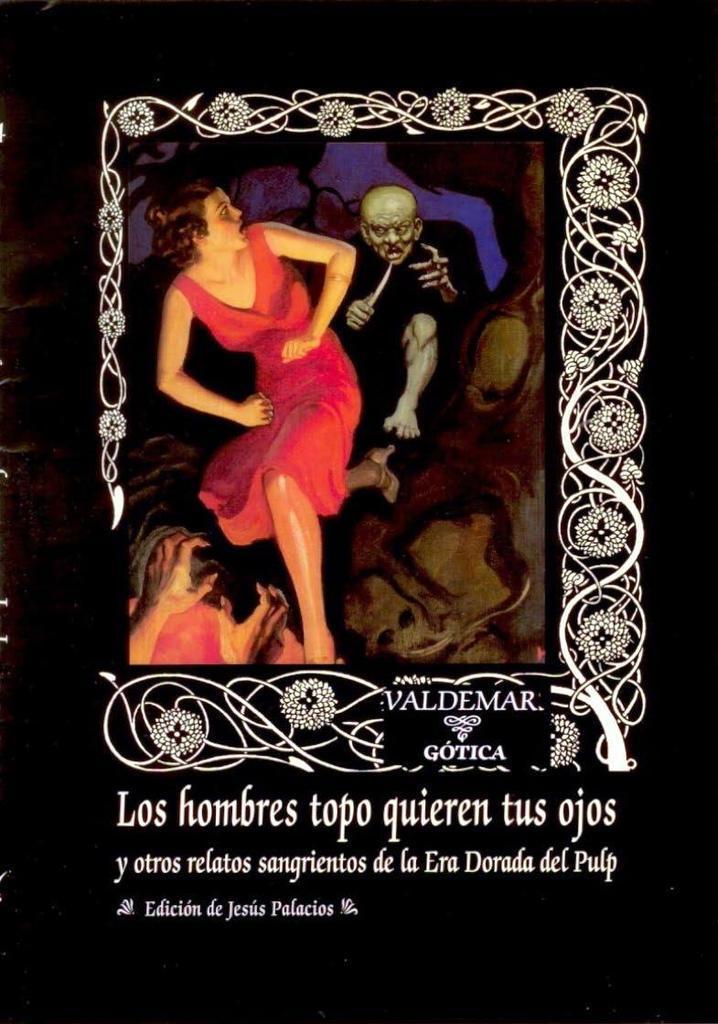Describe this image in one or two sentences. In this image we can see a poster. There are few people and a design on the poster. There is some text written on the poster. 